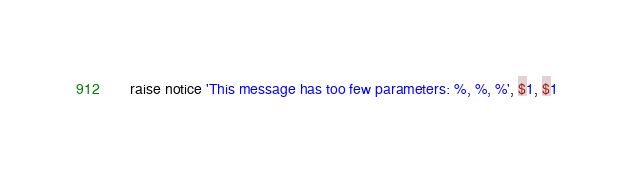Convert code to text. <code><loc_0><loc_0><loc_500><loc_500><_SQL_>    raise notice 'This message has too few parameters: %, %, %', $1, $1
</code> 